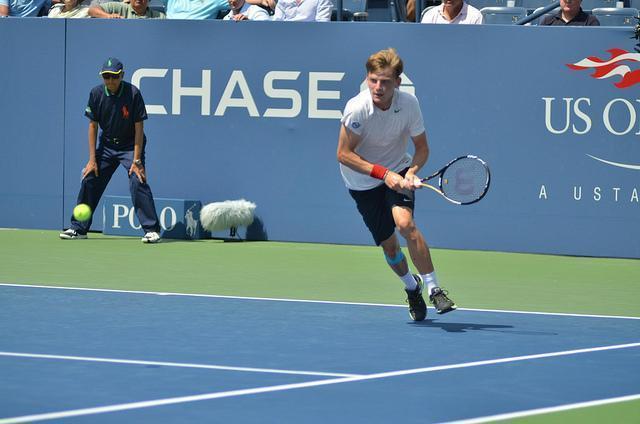What is he doing?
Indicate the correct response by choosing from the four available options to answer the question.
Options: Cleaning up, chasing ball, falling, dropping racquet. Chasing ball. 